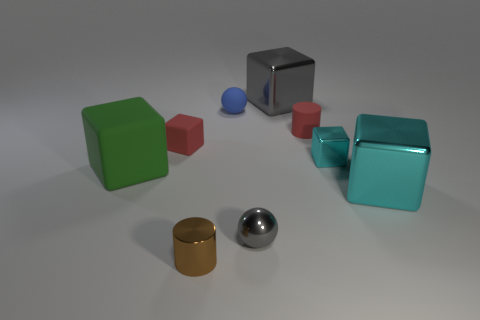The cube that is the same color as the shiny sphere is what size?
Your answer should be very brief. Large. How many things are either metal blocks that are to the left of the big cyan object or big blocks that are on the left side of the blue object?
Make the answer very short. 3. Is the number of tiny red cylinders less than the number of large blue shiny things?
Offer a very short reply. No. What is the material of the other cylinder that is the same size as the metallic cylinder?
Your answer should be very brief. Rubber. Is the size of the cube that is behind the blue object the same as the green thing to the left of the blue matte thing?
Make the answer very short. Yes. Are there any other blue things made of the same material as the small blue object?
Offer a very short reply. No. How many objects are cyan cubes behind the green matte block or big gray things?
Offer a terse response. 2. Does the large block that is on the left side of the matte sphere have the same material as the brown cylinder?
Provide a short and direct response. No. Is the big green matte thing the same shape as the large cyan object?
Give a very brief answer. Yes. There is a tiny sphere in front of the red cylinder; what number of large metal blocks are on the left side of it?
Ensure brevity in your answer.  0. 